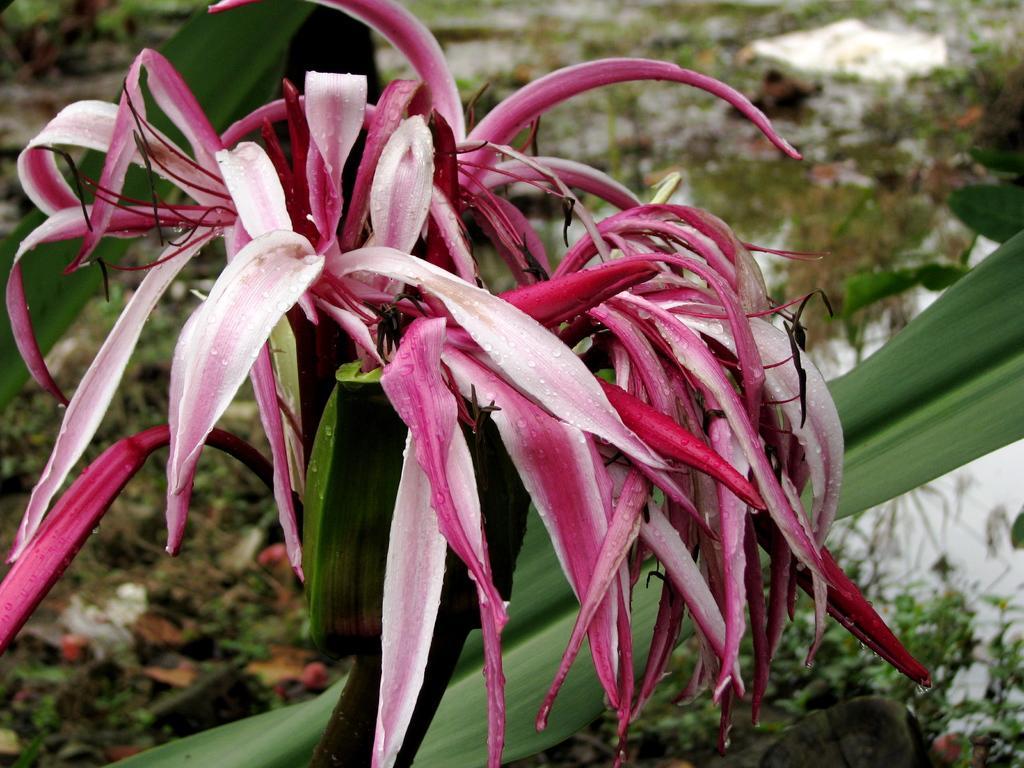How would you summarize this image in a sentence or two? In the picture we can see a plant on it we can see some pink color leaves and under it we can see some grass and water. 